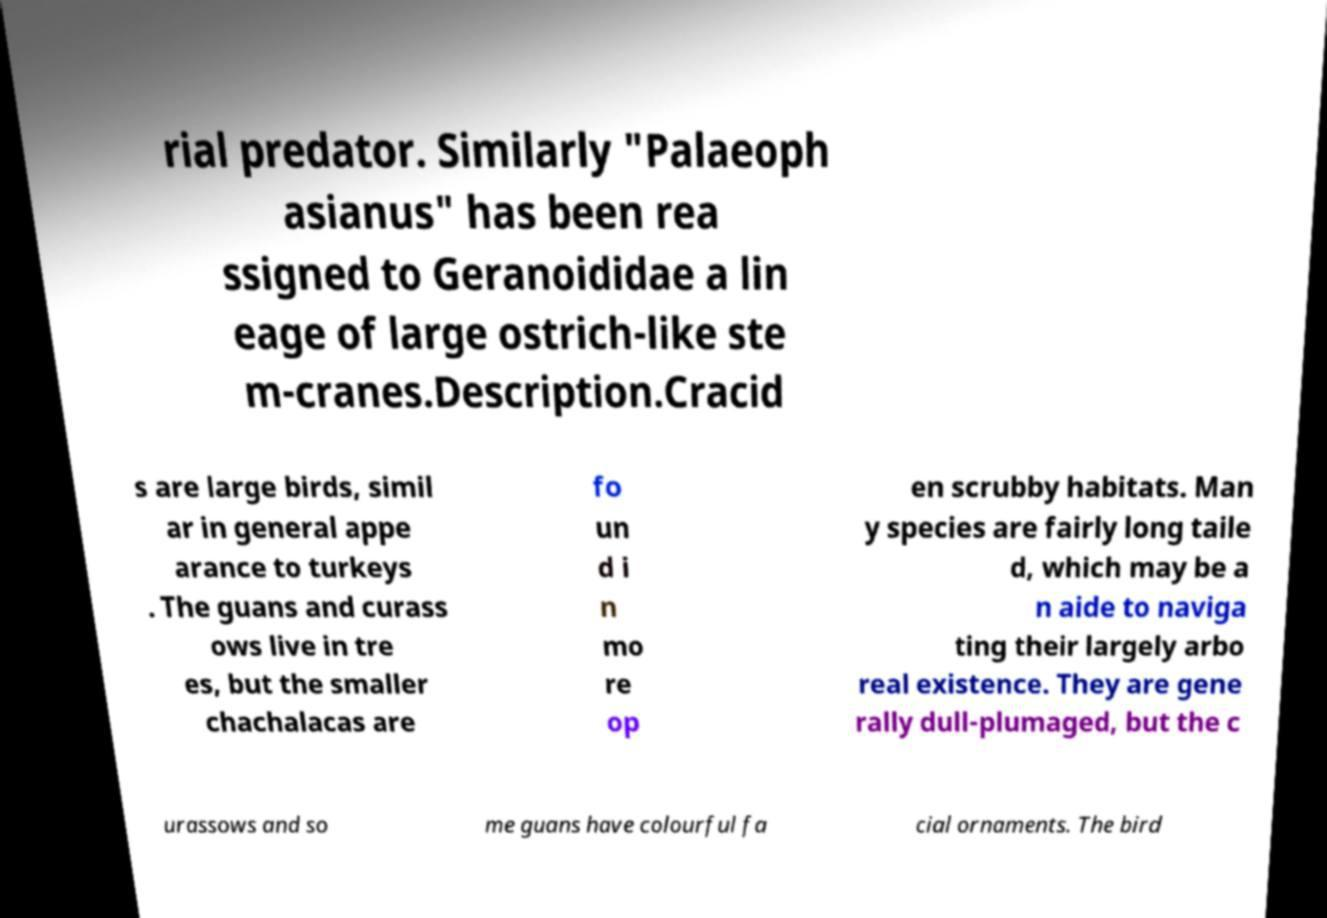I need the written content from this picture converted into text. Can you do that? rial predator. Similarly "Palaeoph asianus" has been rea ssigned to Geranoididae a lin eage of large ostrich-like ste m-cranes.Description.Cracid s are large birds, simil ar in general appe arance to turkeys . The guans and curass ows live in tre es, but the smaller chachalacas are fo un d i n mo re op en scrubby habitats. Man y species are fairly long taile d, which may be a n aide to naviga ting their largely arbo real existence. They are gene rally dull-plumaged, but the c urassows and so me guans have colourful fa cial ornaments. The bird 